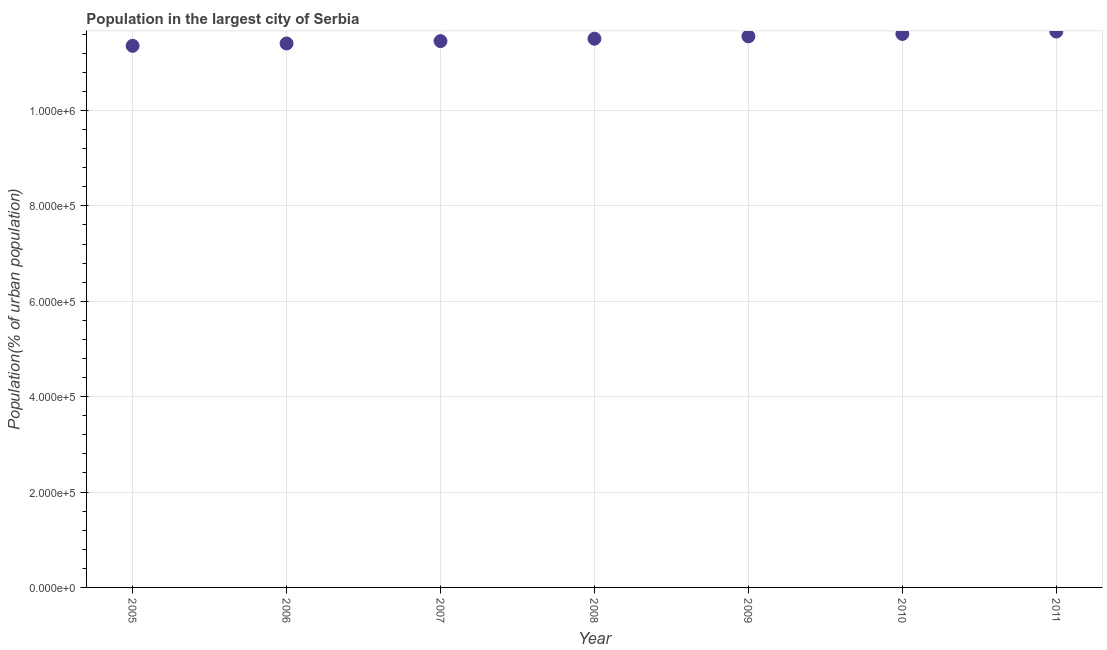What is the population in largest city in 2008?
Keep it short and to the point. 1.15e+06. Across all years, what is the maximum population in largest city?
Offer a very short reply. 1.17e+06. Across all years, what is the minimum population in largest city?
Ensure brevity in your answer.  1.14e+06. In which year was the population in largest city maximum?
Give a very brief answer. 2011. What is the sum of the population in largest city?
Provide a succinct answer. 8.05e+06. What is the difference between the population in largest city in 2007 and 2011?
Your response must be concise. -2.01e+04. What is the average population in largest city per year?
Give a very brief answer. 1.15e+06. What is the median population in largest city?
Make the answer very short. 1.15e+06. Do a majority of the years between 2009 and 2011 (inclusive) have population in largest city greater than 520000 %?
Offer a very short reply. Yes. What is the ratio of the population in largest city in 2005 to that in 2010?
Provide a succinct answer. 0.98. Is the population in largest city in 2010 less than that in 2011?
Your answer should be compact. Yes. Is the difference between the population in largest city in 2006 and 2010 greater than the difference between any two years?
Your answer should be compact. No. What is the difference between the highest and the second highest population in largest city?
Provide a succinct answer. 5047. What is the difference between the highest and the lowest population in largest city?
Offer a terse response. 3.00e+04. Are the values on the major ticks of Y-axis written in scientific E-notation?
Your answer should be compact. Yes. Does the graph contain grids?
Give a very brief answer. Yes. What is the title of the graph?
Give a very brief answer. Population in the largest city of Serbia. What is the label or title of the Y-axis?
Keep it short and to the point. Population(% of urban population). What is the Population(% of urban population) in 2005?
Your answer should be very brief. 1.14e+06. What is the Population(% of urban population) in 2006?
Your response must be concise. 1.14e+06. What is the Population(% of urban population) in 2007?
Your response must be concise. 1.15e+06. What is the Population(% of urban population) in 2008?
Your answer should be very brief. 1.15e+06. What is the Population(% of urban population) in 2009?
Keep it short and to the point. 1.16e+06. What is the Population(% of urban population) in 2010?
Provide a short and direct response. 1.16e+06. What is the Population(% of urban population) in 2011?
Provide a short and direct response. 1.17e+06. What is the difference between the Population(% of urban population) in 2005 and 2006?
Give a very brief answer. -4939. What is the difference between the Population(% of urban population) in 2005 and 2007?
Ensure brevity in your answer.  -9900. What is the difference between the Population(% of urban population) in 2005 and 2008?
Offer a terse response. -1.49e+04. What is the difference between the Population(% of urban population) in 2005 and 2009?
Give a very brief answer. -1.99e+04. What is the difference between the Population(% of urban population) in 2005 and 2010?
Keep it short and to the point. -2.49e+04. What is the difference between the Population(% of urban population) in 2005 and 2011?
Give a very brief answer. -3.00e+04. What is the difference between the Population(% of urban population) in 2006 and 2007?
Give a very brief answer. -4961. What is the difference between the Population(% of urban population) in 2006 and 2008?
Keep it short and to the point. -9950. What is the difference between the Population(% of urban population) in 2006 and 2009?
Make the answer very short. -1.49e+04. What is the difference between the Population(% of urban population) in 2006 and 2010?
Ensure brevity in your answer.  -2.00e+04. What is the difference between the Population(% of urban population) in 2006 and 2011?
Ensure brevity in your answer.  -2.50e+04. What is the difference between the Population(% of urban population) in 2007 and 2008?
Provide a short and direct response. -4989. What is the difference between the Population(% of urban population) in 2007 and 2009?
Keep it short and to the point. -9985. What is the difference between the Population(% of urban population) in 2007 and 2010?
Your answer should be compact. -1.50e+04. What is the difference between the Population(% of urban population) in 2007 and 2011?
Offer a terse response. -2.01e+04. What is the difference between the Population(% of urban population) in 2008 and 2009?
Give a very brief answer. -4996. What is the difference between the Population(% of urban population) in 2008 and 2010?
Your response must be concise. -1.00e+04. What is the difference between the Population(% of urban population) in 2008 and 2011?
Keep it short and to the point. -1.51e+04. What is the difference between the Population(% of urban population) in 2009 and 2010?
Your response must be concise. -5026. What is the difference between the Population(% of urban population) in 2009 and 2011?
Make the answer very short. -1.01e+04. What is the difference between the Population(% of urban population) in 2010 and 2011?
Provide a succinct answer. -5047. What is the ratio of the Population(% of urban population) in 2005 to that in 2008?
Provide a succinct answer. 0.99. What is the ratio of the Population(% of urban population) in 2006 to that in 2007?
Make the answer very short. 1. What is the ratio of the Population(% of urban population) in 2006 to that in 2009?
Make the answer very short. 0.99. What is the ratio of the Population(% of urban population) in 2007 to that in 2010?
Your response must be concise. 0.99. What is the ratio of the Population(% of urban population) in 2007 to that in 2011?
Give a very brief answer. 0.98. What is the ratio of the Population(% of urban population) in 2008 to that in 2011?
Give a very brief answer. 0.99. What is the ratio of the Population(% of urban population) in 2010 to that in 2011?
Provide a succinct answer. 1. 